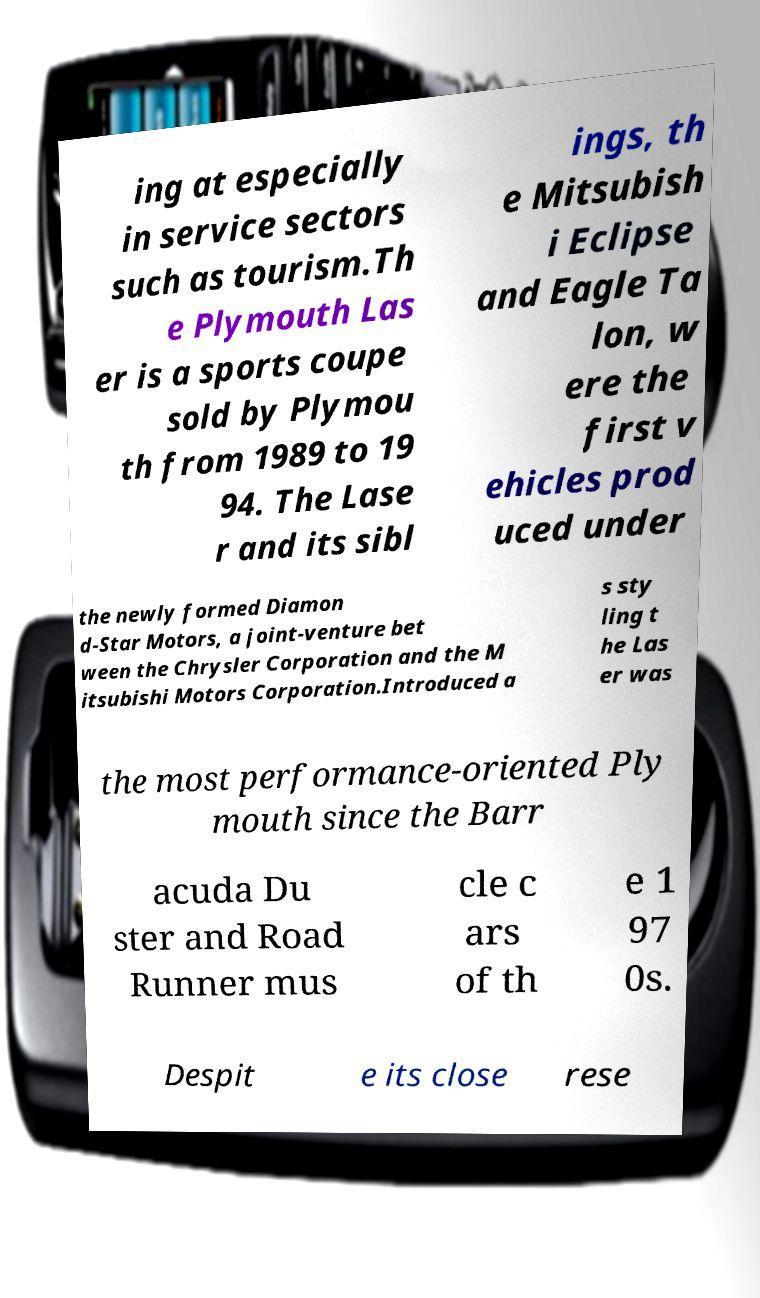Please identify and transcribe the text found in this image. ing at especially in service sectors such as tourism.Th e Plymouth Las er is a sports coupe sold by Plymou th from 1989 to 19 94. The Lase r and its sibl ings, th e Mitsubish i Eclipse and Eagle Ta lon, w ere the first v ehicles prod uced under the newly formed Diamon d-Star Motors, a joint-venture bet ween the Chrysler Corporation and the M itsubishi Motors Corporation.Introduced a s sty ling t he Las er was the most performance-oriented Ply mouth since the Barr acuda Du ster and Road Runner mus cle c ars of th e 1 97 0s. Despit e its close rese 